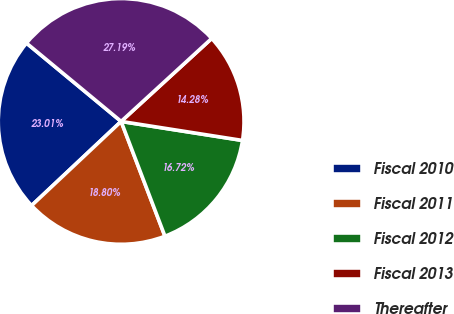Convert chart. <chart><loc_0><loc_0><loc_500><loc_500><pie_chart><fcel>Fiscal 2010<fcel>Fiscal 2011<fcel>Fiscal 2012<fcel>Fiscal 2013<fcel>Thereafter<nl><fcel>23.01%<fcel>18.8%<fcel>16.72%<fcel>14.28%<fcel>27.19%<nl></chart> 